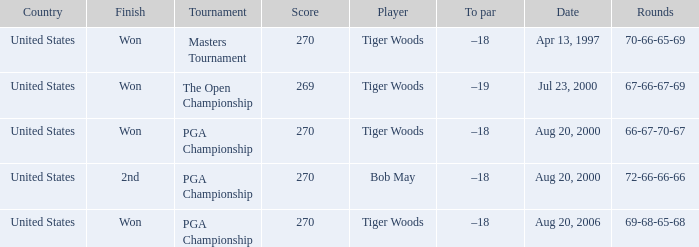What is the worst (highest) score? 270.0. 